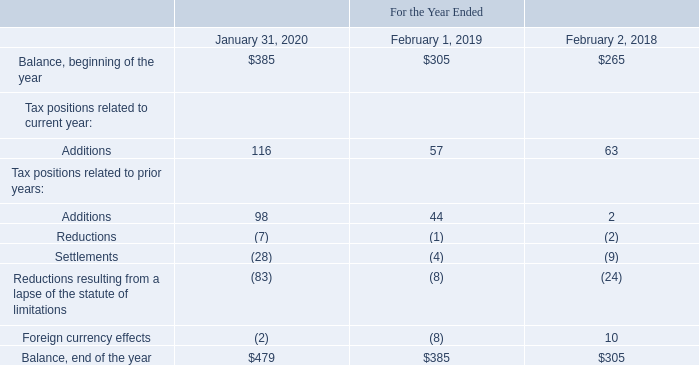Unrecognized Tax Benefits
A reconciliation of the beginning and ending amount of gross unrecognized tax benefits, excluding interest and penalties associated with unrecognized tax benefits, for the periods presented is as follows (table in millions):
Of the net unrecognized tax benefits, including interest and penalties, $323 million and $296 million were included in income tax payable on the consolidated balance sheets as of January 31, 2020 and February 1, 2019, respectively. Approximately $313 million and $266 million, respectively, would, if recognized, benefit VMware's annual effective income tax rate. VMware includes interest expense and penalties related to income tax matters in the income tax provision. VMware had accrued $48 million and $56 million of interest and penalties associated with unrecognized tax benefits as of January 31, 2020 and February 1, 2019, respectively. Income tax expense during the year ended February 1, 2019 included interest and penalties associated with uncertain tax positions of $15 million. Interest and penalties associated with uncertain tax positions included in income tax expense (benefit) were not significant during the years ended January 31, 2020 and February 2, 2018.
The Dell-owned EMC consolidated group is routinely under audit by the IRS. All U.S. federal income tax matters have been concluded for years through 2015 while VMware was part of the Dell-owned EMC consolidated group. The IRS has started its examination of fiscal years 2015 through 2019 for the Dell consolidated group, which VMware was part of beginning fiscal 2017. In addition, VMware is under corporate income tax audits in various states and non-U.S. jurisdictions. Consistent with the Company’s historical practices under the tax sharing agreement with EMC, when VMware becomes subject to federal tax audits as a member of Dell’s consolidated group, the tax sharing agreement provides that Dell has authority to control the audit and represent Dell’s and VMware’s interests to the IRS.
Open tax years subject to examinations for larger non-U.S. jurisdictions vary beginning in 2008. Audit outcomes and the timing of audit settlements are subject to significant uncertainty. When considering the outcomes and the timing of tax examinations, the expiration of statutes of limitations for specific jurisdictions, or the timing and result of ruling requests from taxing authorities, it is reasonably possible that total unrecognized tax benefits could be potentially reduced by approximately $17 million within the next 12 months.
Which years does the table provide information for a reconciliation of the beginning and ending amount of gross unrecognized tax benefits, excluding interest and penalties associated with unrecognized tax benefits? 2020, 2019, 2018. What were the additions to tax positions related to current year in 2020?
Answer scale should be: million. 116. What were the settlements for tax positions related to prior years in 2019?
Answer scale should be: million. (4). What was the change in the balance at the beginning of the year between 2019 and 2020?
Answer scale should be: million. 385-305
Answer: 80. How many years did additions to tax positions related to prior years exceed $50 million? 2020
Answer: 1. What was the percentage change in the balance at the end of the year between 2019 and 2020?
Answer scale should be: percent. (479-385)/385
Answer: 24.42. 